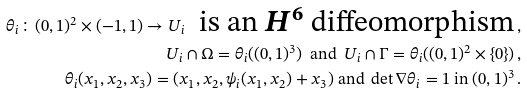Convert formula to latex. <formula><loc_0><loc_0><loc_500><loc_500>\theta _ { i } \colon ( 0 , 1 ) ^ { 2 } \times ( - 1 , 1 ) \rightarrow U _ { i } \ \text { is an $H^{6}$ diffeomorphism} \, , \\ U _ { i } \cap \Omega = \theta _ { i } ( ( 0 , 1 ) ^ { 3 } ) \ \text { and } \ U _ { i } \cap \Gamma = \theta _ { i } ( ( 0 , 1 ) ^ { 2 } \times \{ 0 \} ) \, , \\ \theta _ { i } ( x _ { 1 } , x _ { 2 } , x _ { 3 } ) = ( x _ { 1 } , x _ { 2 } , \psi _ { i } ( x _ { 1 } , x _ { 2 } ) + x _ { 3 } ) \text { and } \det \nabla \theta _ { i } = 1 \text { in } ( 0 , 1 ) ^ { 3 } \, .</formula> 